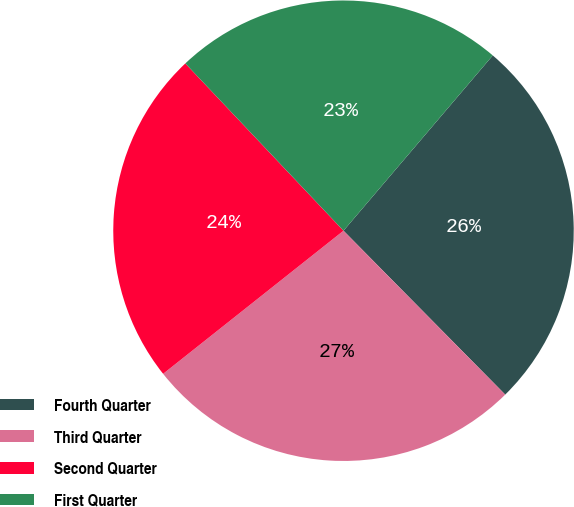Convert chart to OTSL. <chart><loc_0><loc_0><loc_500><loc_500><pie_chart><fcel>Fourth Quarter<fcel>Third Quarter<fcel>Second Quarter<fcel>First Quarter<nl><fcel>26.38%<fcel>26.72%<fcel>23.62%<fcel>23.28%<nl></chart> 